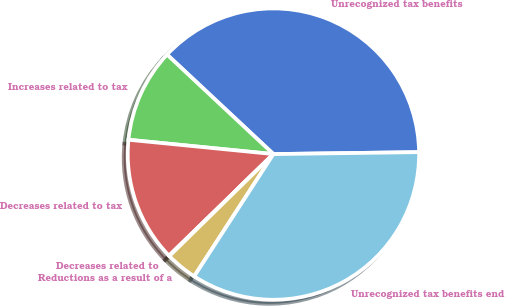<chart> <loc_0><loc_0><loc_500><loc_500><pie_chart><fcel>Unrecognized tax benefits<fcel>Increases related to tax<fcel>Decreases related to tax<fcel>Decreases related to<fcel>Reductions as a result of a<fcel>Unrecognized tax benefits end<nl><fcel>37.82%<fcel>10.4%<fcel>13.85%<fcel>0.06%<fcel>3.51%<fcel>34.37%<nl></chart> 